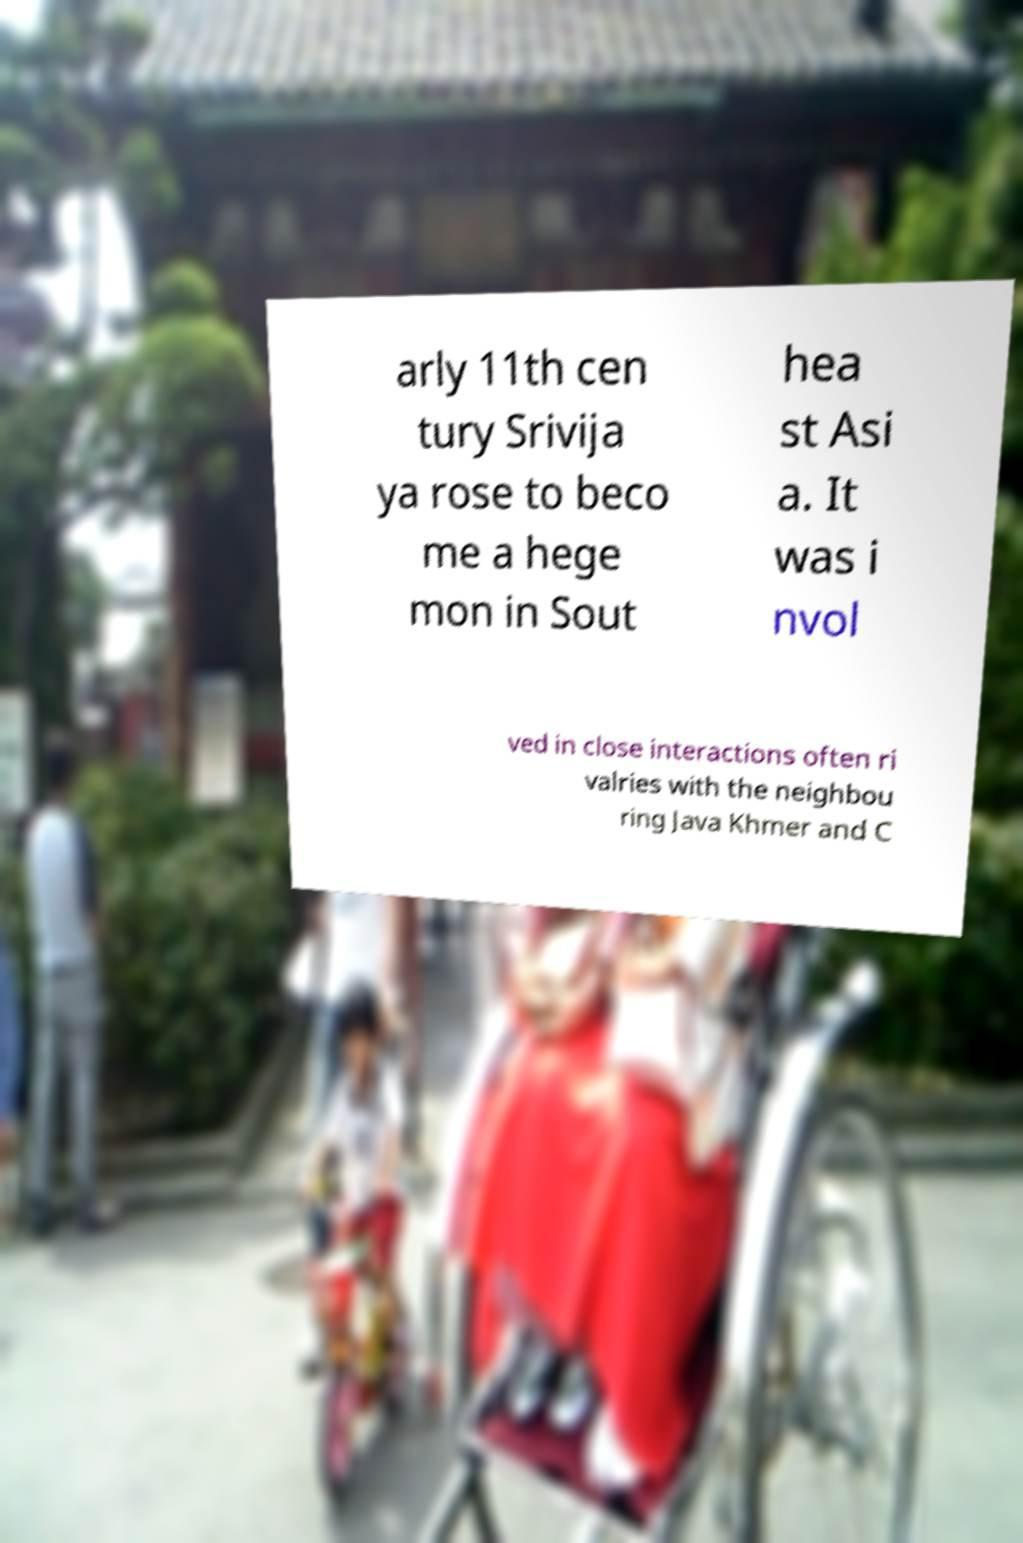Could you assist in decoding the text presented in this image and type it out clearly? arly 11th cen tury Srivija ya rose to beco me a hege mon in Sout hea st Asi a. It was i nvol ved in close interactions often ri valries with the neighbou ring Java Khmer and C 